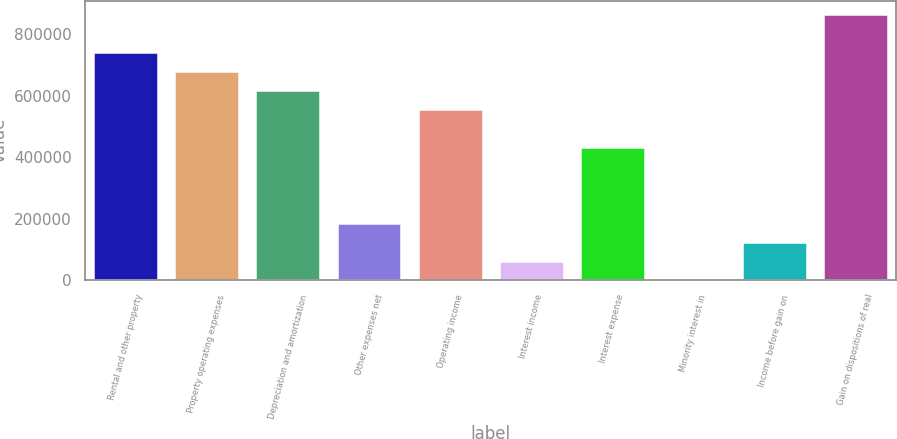Convert chart to OTSL. <chart><loc_0><loc_0><loc_500><loc_500><bar_chart><fcel>Rental and other property<fcel>Property operating expenses<fcel>Depreciation and amortization<fcel>Other expenses net<fcel>Operating income<fcel>Interest income<fcel>Interest expense<fcel>Minority interest in<fcel>Income before gain on<fcel>Gain on dispositions of real<nl><fcel>741693<fcel>679930<fcel>618168<fcel>185830<fcel>556406<fcel>62305.5<fcel>432880<fcel>543<fcel>124068<fcel>865218<nl></chart> 